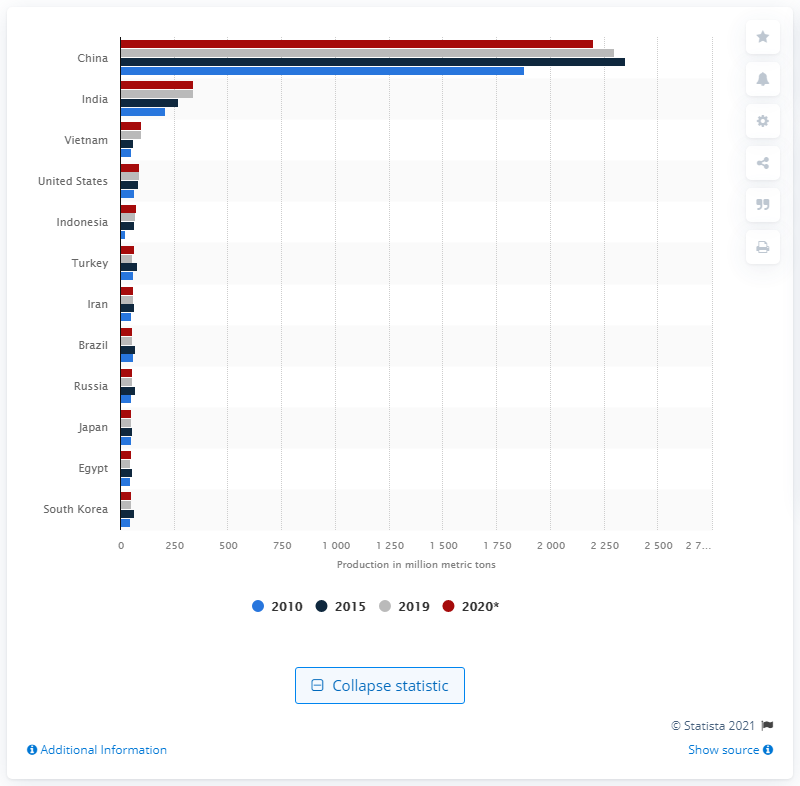Point out several critical features in this image. According to data from 2020, the United States produced approximately 90 million metric tons of cement. 